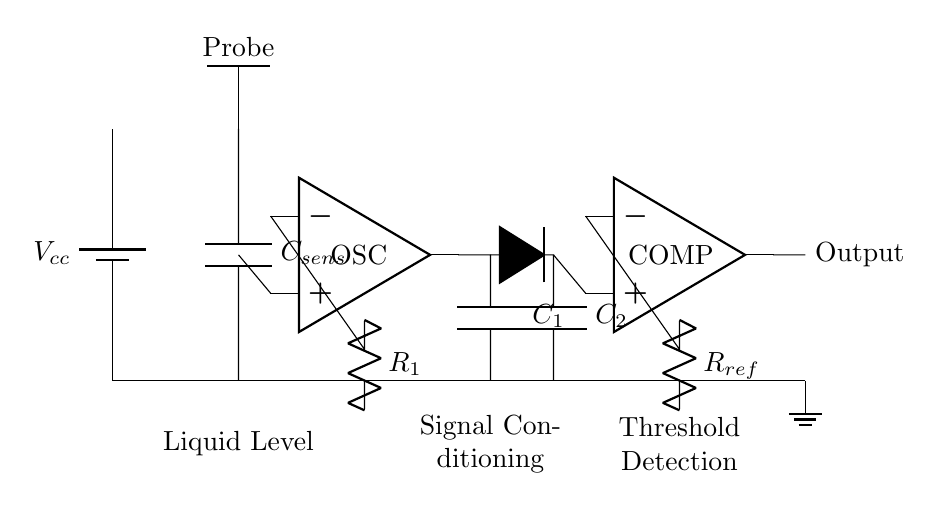What is the primary function of the capacitive sensor in this circuit? The primary function of the capacitive sensor is to detect the liquid level by measuring the change in capacitance when the liquid is present or absent.
Answer: Liquid level detection What component is used for signal conditioning? The component used for signal conditioning in this circuit is the oscillator, indicated by the op-amp symbol.
Answer: OSC What is the reference resistor labeled in the circuit? The reference resistor in the circuit is labeled as R_ref, which is used to set the threshold level for comparison.
Answer: R_ref How many capacitors are present in the circuit? There are three capacitors present in the circuit: C_sens, C_1, and C_2.
Answer: Three What role does the comparator play in the circuit? The comparator compares the output signal from the signal conditioning section to a reference voltage to determine if the liquid level is above or below a certain point.
Answer: Threshold detection What does the output node indicate? The output node represents the signal that indicates whether the liquid level has crossed the threshold set by the comparator, effectively serving as the output for the liquid level detection.
Answer: Output 